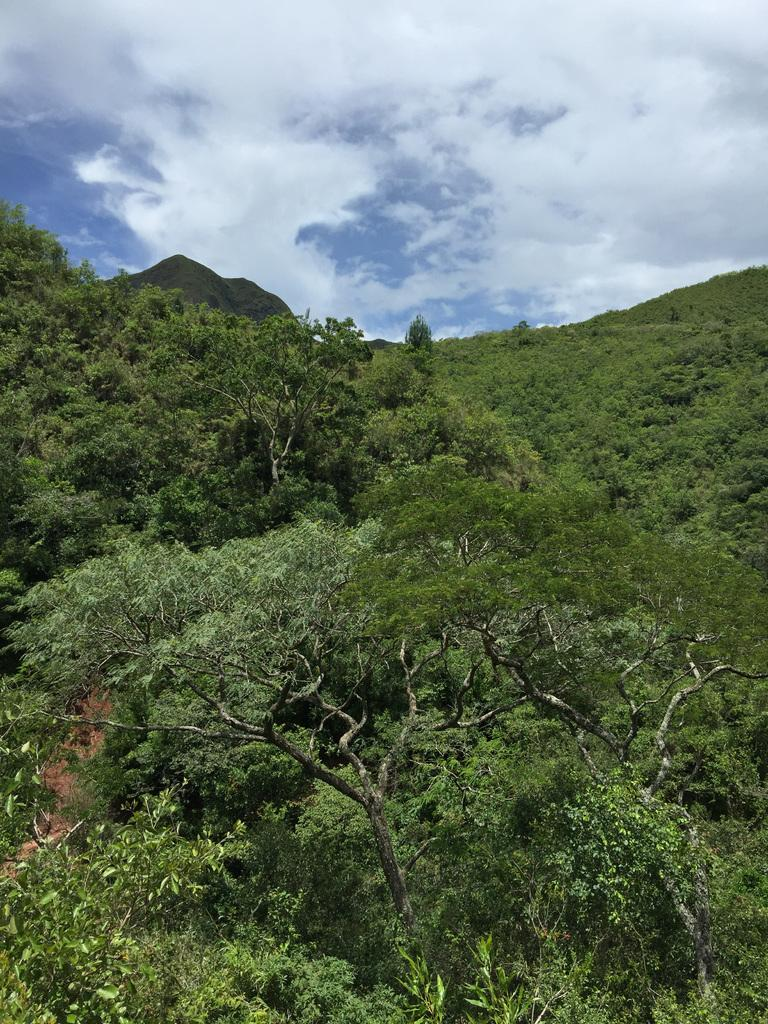What type of vegetation can be seen in the image? There are trees in the image. What can be found on the ground in the image? There is a path in the image. What type of terrain is visible in the image? There are hills in the image. What is visible at the top of the image? The sky is visible at the top of the image. What is the condition of the sky in the image? The sky appears to be cloudy. Can you tell me how many buns are being shared by friends in the image? There are no buns or friends present in the image. What type of error can be seen in the image? There is no error present in the image. 